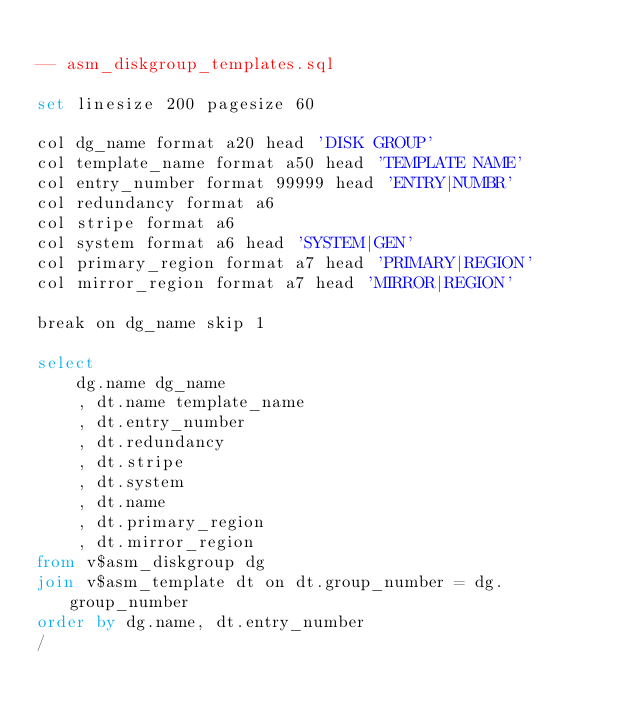Convert code to text. <code><loc_0><loc_0><loc_500><loc_500><_SQL_>
-- asm_diskgroup_templates.sql

set linesize 200 pagesize 60

col dg_name format a20 head 'DISK GROUP'
col template_name format a50 head 'TEMPLATE NAME'
col entry_number format 99999 head 'ENTRY|NUMBR'
col redundancy format a6
col stripe format a6
col system format a6 head 'SYSTEM|GEN'
col primary_region format a7 head 'PRIMARY|REGION'
col mirror_region format a7 head 'MIRROR|REGION'

break on dg_name skip 1

select
	dg.name dg_name
	, dt.name template_name
	, dt.entry_number
	, dt.redundancy
	, dt.stripe
	, dt.system
	, dt.name
	, dt.primary_region
	, dt.mirror_region
from v$asm_diskgroup dg
join v$asm_template dt on dt.group_number = dg.group_number
order by dg.name, dt.entry_number
/

</code> 